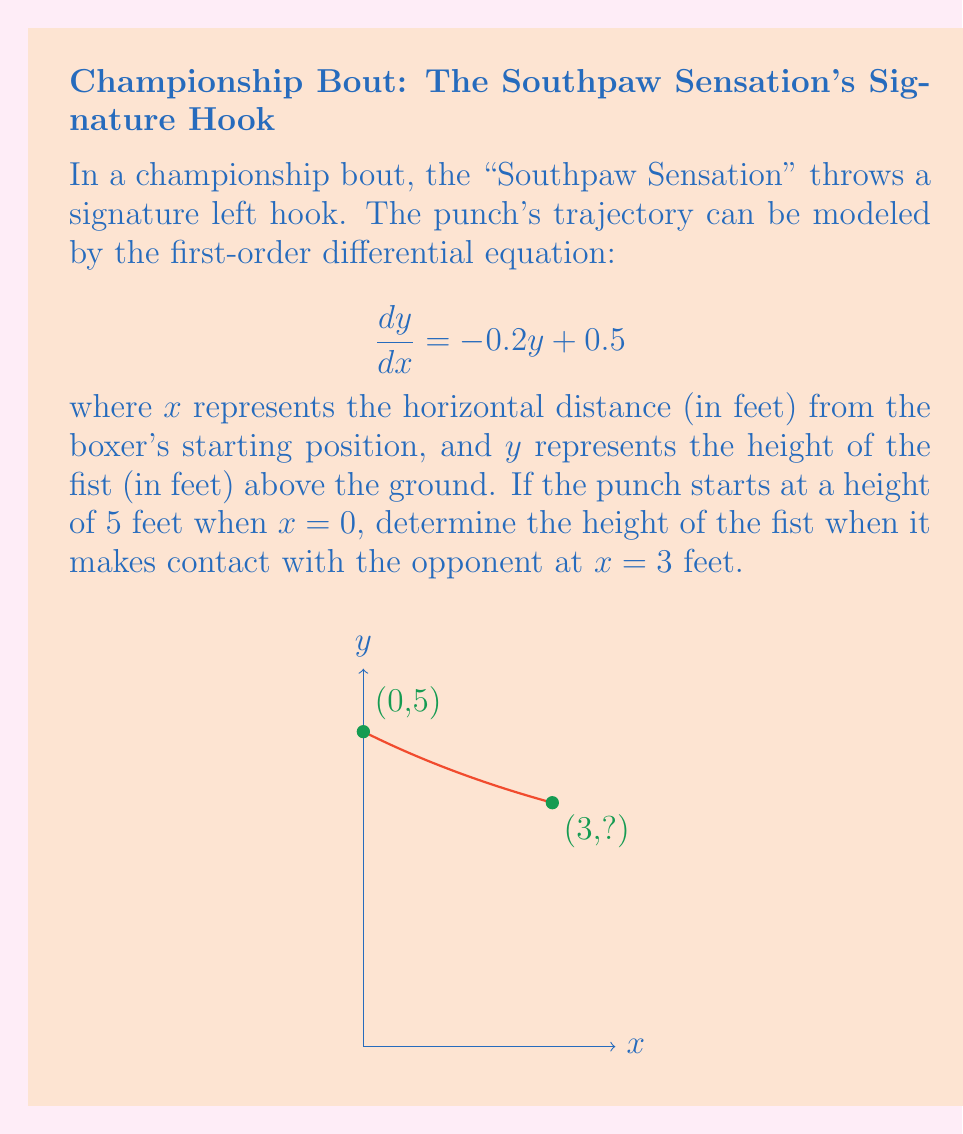Give your solution to this math problem. Let's solve this step-by-step:

1) The given differential equation is:

   $$\frac{dy}{dx} = -0.2y + 0.5$$

2) This is a linear first-order differential equation of the form:

   $$\frac{dy}{dx} + P(x)y = Q(x)$$

   where $P(x) = 0.2$ and $Q(x) = 0.5$

3) The general solution for this type of equation is:

   $$y = e^{-\int P(x)dx} \left(\int Q(x)e^{\int P(x)dx}dx + C\right)$$

4) Solving the integrals:

   $\int P(x)dx = \int 0.2 dx = 0.2x$
   
   $e^{\int P(x)dx} = e^{0.2x}$

5) Substituting into the general solution:

   $$y = e^{-0.2x} \left(\int 0.5e^{0.2x}dx + C\right)$$

6) Solving the remaining integral:

   $$y = e^{-0.2x} \left(\frac{0.5}{0.2}e^{0.2x} + C\right) = 2.5 + Ce^{-0.2x}$$

7) Using the initial condition $y(0) = 5$:

   $5 = 2.5 + C$
   $C = 2.5$

8) Therefore, the particular solution is:

   $$y = 2.5 + 2.5e^{-0.2x}$$

9) To find the height at $x = 3$, we substitute:

   $$y(3) = 2.5 + 2.5e^{-0.2(3)} = 2.5 + 2.5e^{-0.6} \approx 3.86$$
Answer: $3.86$ feet 